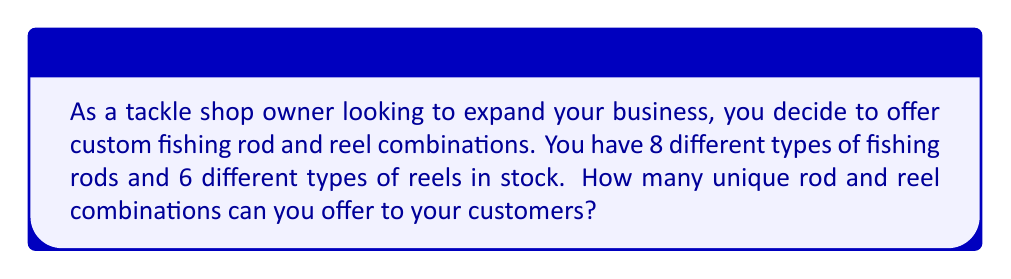Teach me how to tackle this problem. To solve this problem, we can use the multiplication principle of combinatorics. The multiplication principle states that if we have $m$ ways of doing one thing and $n$ ways of doing another thing, then there are $m \times n$ ways of doing both things.

In this case:
1. We have 8 different types of fishing rods to choose from.
2. For each rod, we have 6 different types of reels to choose from.

Therefore, the total number of unique combinations is:

$$ \text{Total combinations} = \text{Number of rods} \times \text{Number of reels} $$

$$ \text{Total combinations} = 8 \times 6 $$

$$ \text{Total combinations} = 48 $$

This means that for each rod, there are 6 possible reel choices, and we have 8 rods in total. Multiplying these together gives us the total number of unique combinations.
Answer: $48$ unique rod and reel combinations 